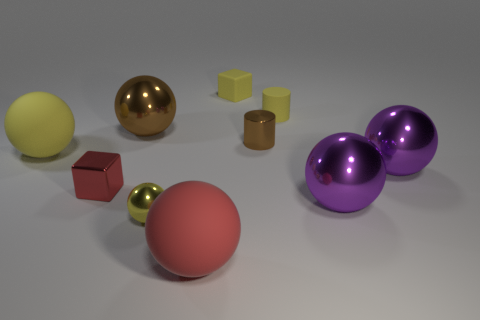Subtract all red matte balls. How many balls are left? 5 Subtract all purple balls. How many balls are left? 4 Subtract 2 blocks. How many blocks are left? 0 Subtract all green spheres. How many yellow cylinders are left? 1 Add 5 big gray metal blocks. How many big gray metal blocks exist? 5 Subtract 0 gray cubes. How many objects are left? 10 Subtract all cylinders. How many objects are left? 8 Subtract all blue balls. Subtract all brown cylinders. How many balls are left? 6 Subtract all small red metallic balls. Subtract all red metallic cubes. How many objects are left? 9 Add 7 tiny cubes. How many tiny cubes are left? 9 